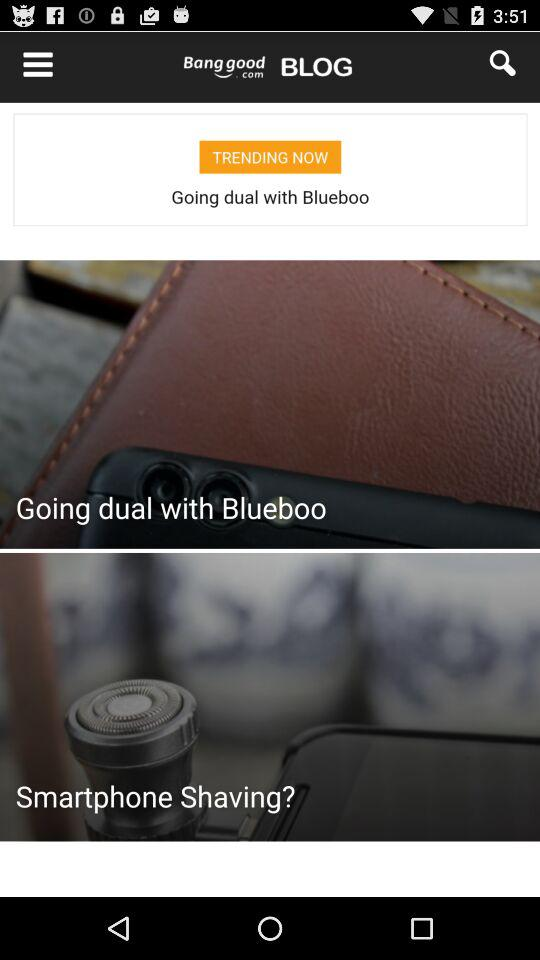What is the number of answers for the given item? The number of answers for the given item is 1. 